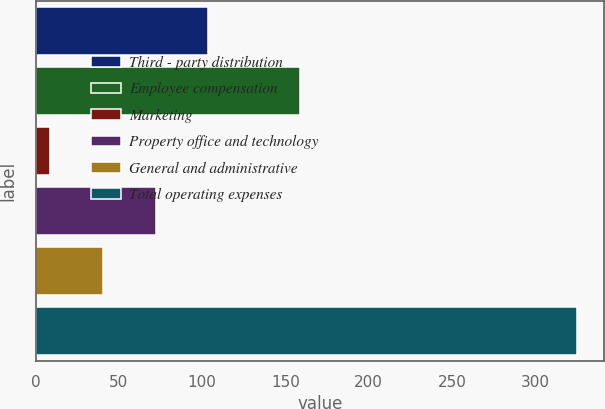Convert chart. <chart><loc_0><loc_0><loc_500><loc_500><bar_chart><fcel>Third - party distribution<fcel>Employee compensation<fcel>Marketing<fcel>Property office and technology<fcel>General and administrative<fcel>Total operating expenses<nl><fcel>103.79<fcel>158.6<fcel>8.9<fcel>72.16<fcel>40.53<fcel>325.2<nl></chart> 